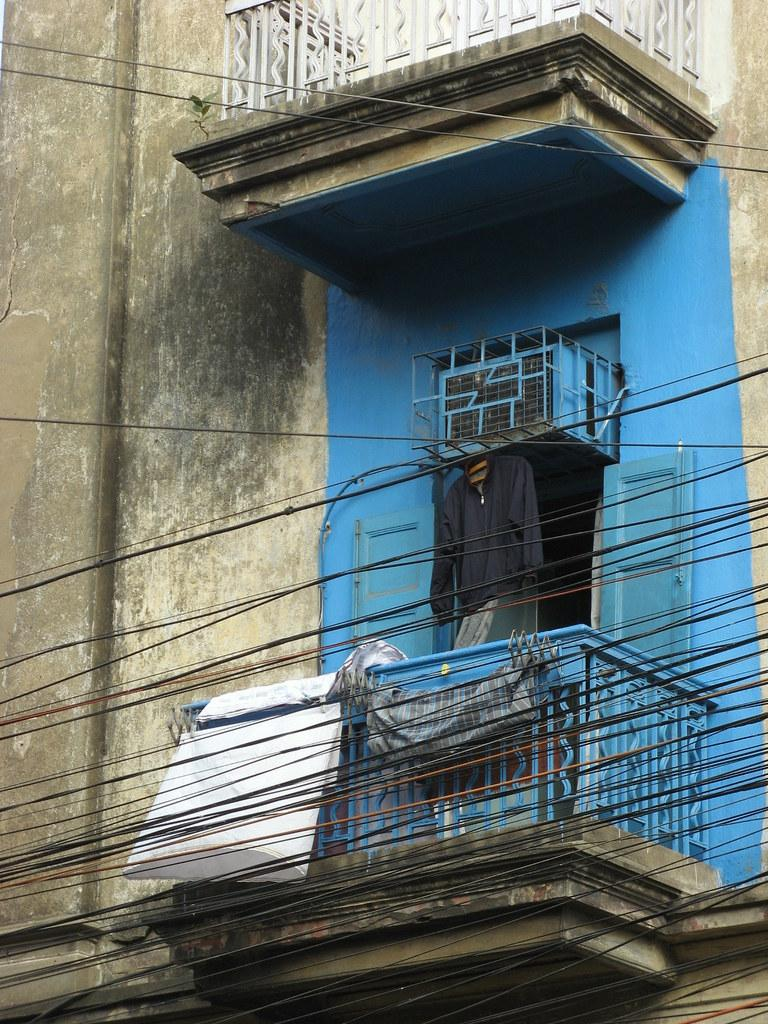What type of structure is visible in the image? There is a building wall in the image. What is a feature of the building wall? There is a door in the image. What appliance can be seen attached to the building wall? There is an air conditioner in the image. What else is visible in the image besides the building wall? There are clothes visible in the image. What type of barrier is present in the image? There is a fence in the image. What else can be seen in the image besides the building wall and its features? There are many electrical wires in the image. Can you hear the bells ringing in the image? There are no bells present in the image, so it is not possible to hear them ringing. 